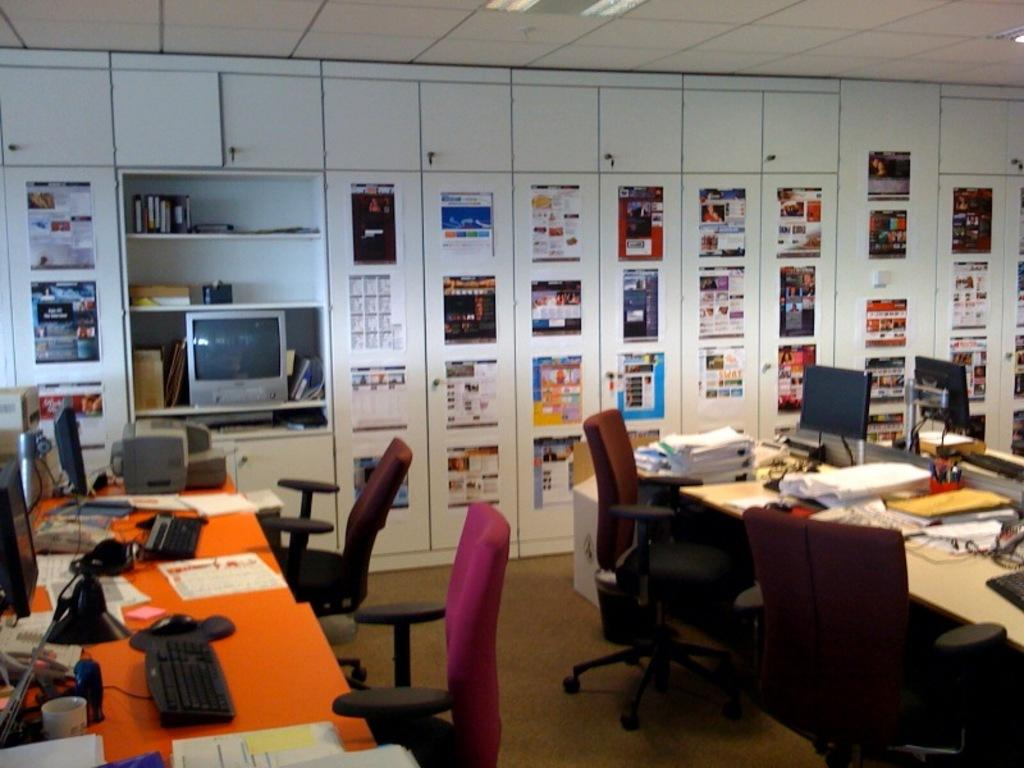What type of furniture is present in the image? There are cupboards, tables, and chairs in the image. What electronic devices can be seen in the image? There is a television, laptops, keyboards, and mouses in the image. What items are used for storage and display in the image? There are cupboards and shelves in the image. What items are used for reading and writing in the image? There are books, papers, and pens in the image. What type of plantation is visible in the image? There is no plantation present in the image. How does the yak feel about being in the image? There is no yak present in the image, so it cannot have any feelings about being in the image. 